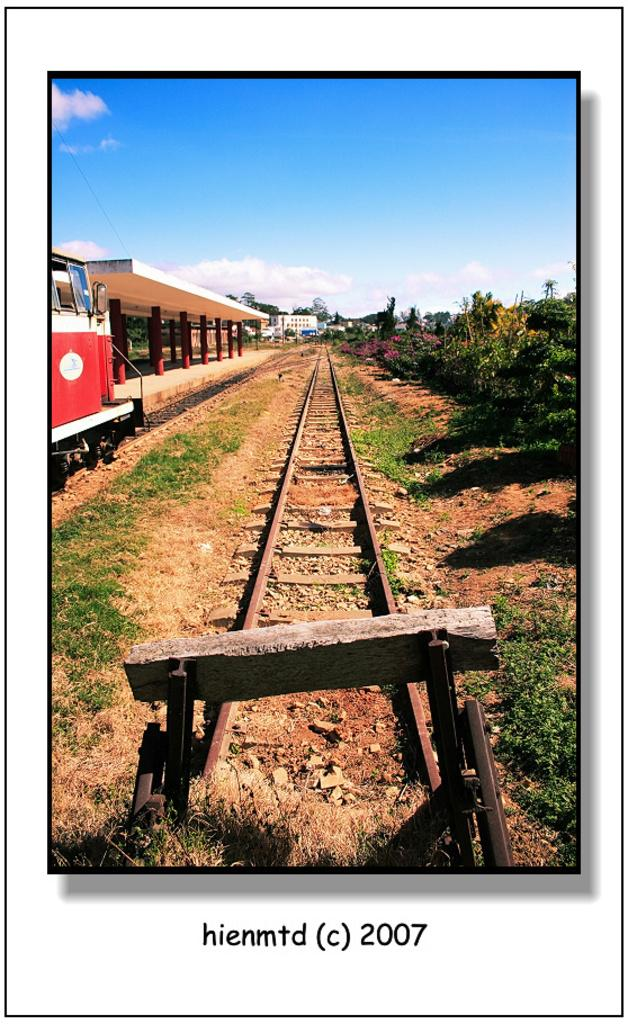<image>
Share a concise interpretation of the image provided. An old railroad track that had a photo taken of it in 2007. 